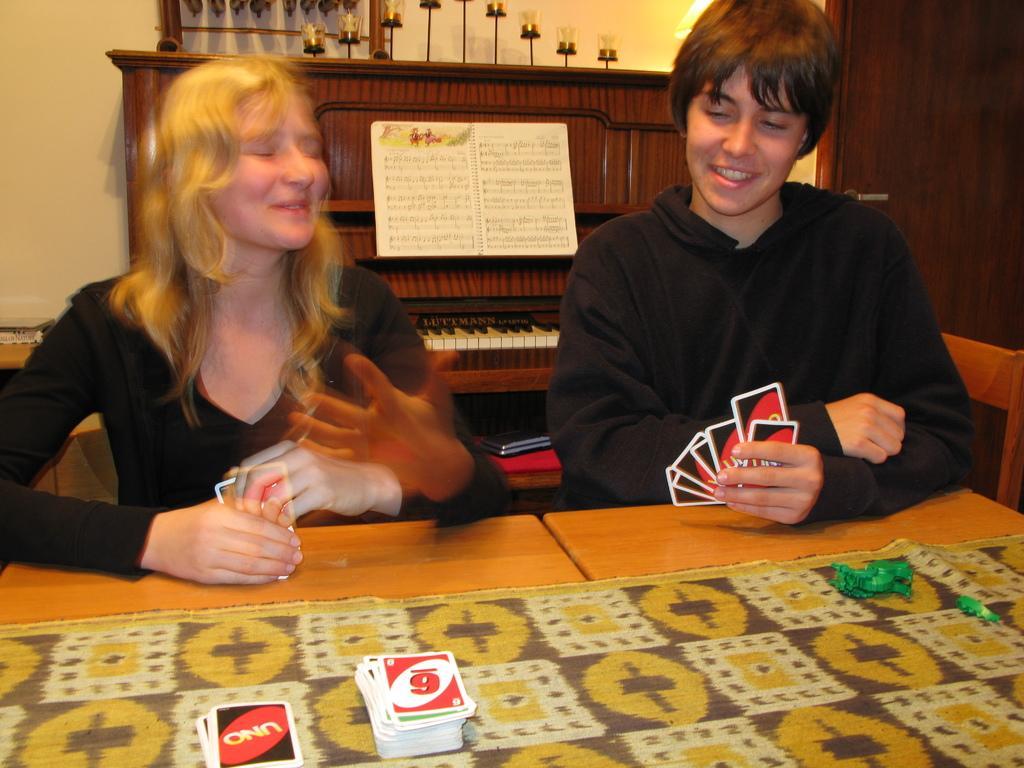How would you summarize this image in a sentence or two? In this picture we can see two persons holding cards in their hands and smiling and in front of them there is table and on table we can see cards, toy, cloth and in background we can see piano with musical notes, wall. 